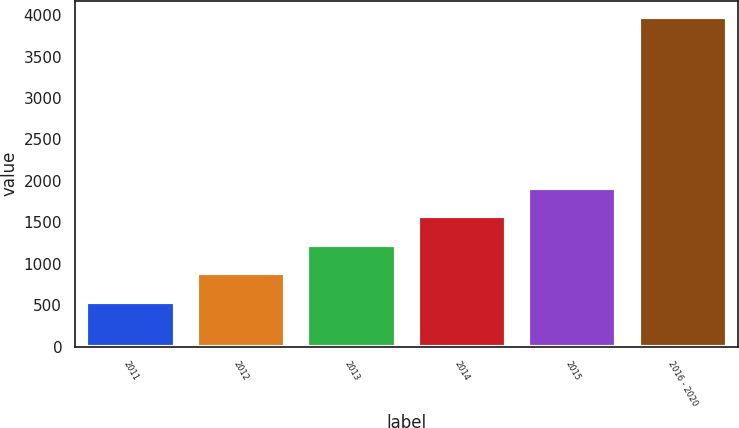Convert chart to OTSL. <chart><loc_0><loc_0><loc_500><loc_500><bar_chart><fcel>2011<fcel>2012<fcel>2013<fcel>2014<fcel>2015<fcel>2016 - 2020<nl><fcel>545<fcel>887.9<fcel>1230.8<fcel>1573.7<fcel>1916.6<fcel>3974<nl></chart> 